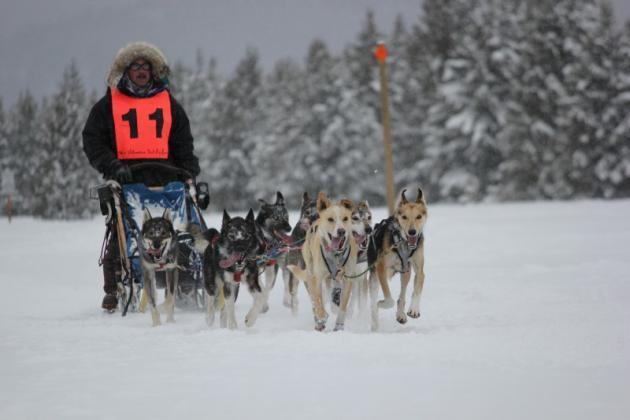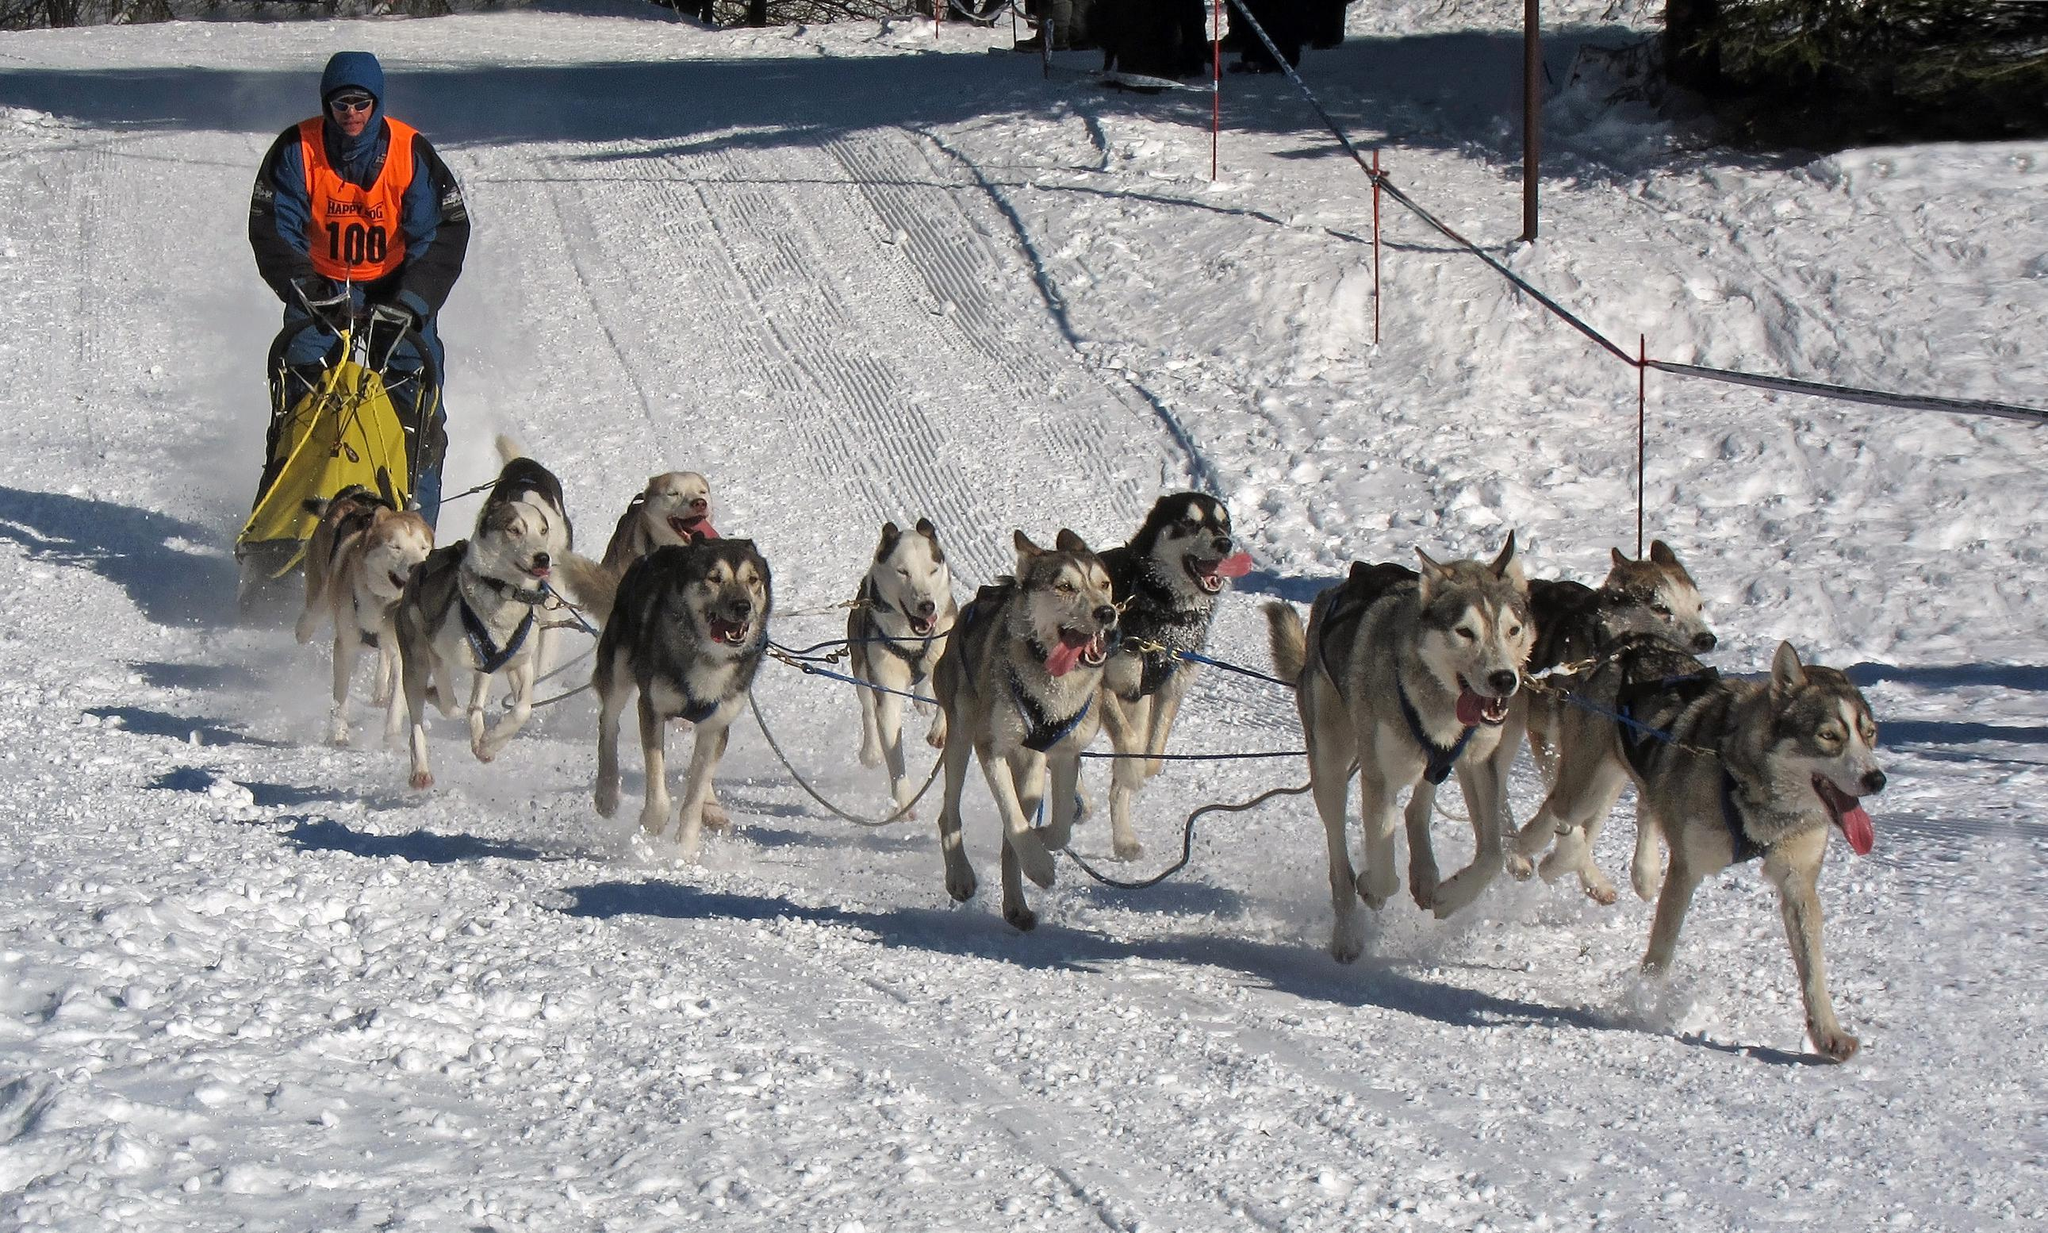The first image is the image on the left, the second image is the image on the right. Assess this claim about the two images: "Left image shows a rider with an orange vest at the left of the picture.". Correct or not? Answer yes or no. Yes. 